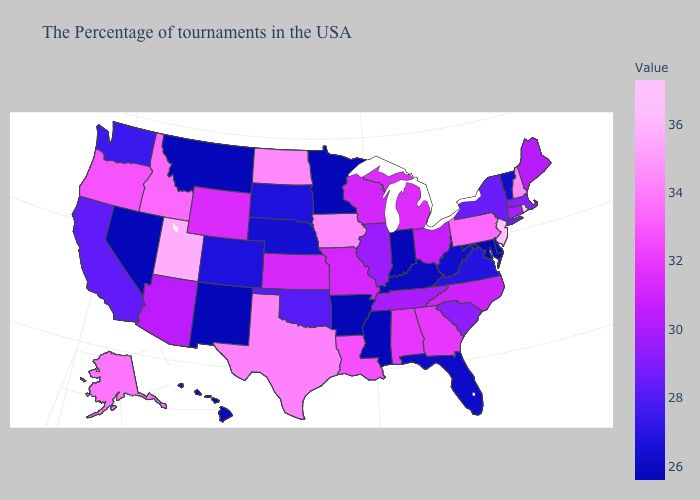Among the states that border New York , does Vermont have the highest value?
Give a very brief answer. No. Which states have the lowest value in the USA?
Quick response, please. Delaware, Maryland, Indiana, Mississippi, Arkansas, Minnesota, New Mexico, Montana, Nevada. Which states hav the highest value in the MidWest?
Write a very short answer. Iowa, North Dakota. Which states have the lowest value in the West?
Write a very short answer. New Mexico, Montana, Nevada. Does Rhode Island have the highest value in the USA?
Write a very short answer. Yes. 